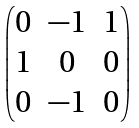Convert formula to latex. <formula><loc_0><loc_0><loc_500><loc_500>\begin{pmatrix} 0 & - 1 & 1 \\ 1 & 0 & 0 \\ 0 & - 1 & 0 \end{pmatrix}</formula> 